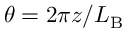<formula> <loc_0><loc_0><loc_500><loc_500>\theta = 2 \pi z / L _ { B }</formula> 